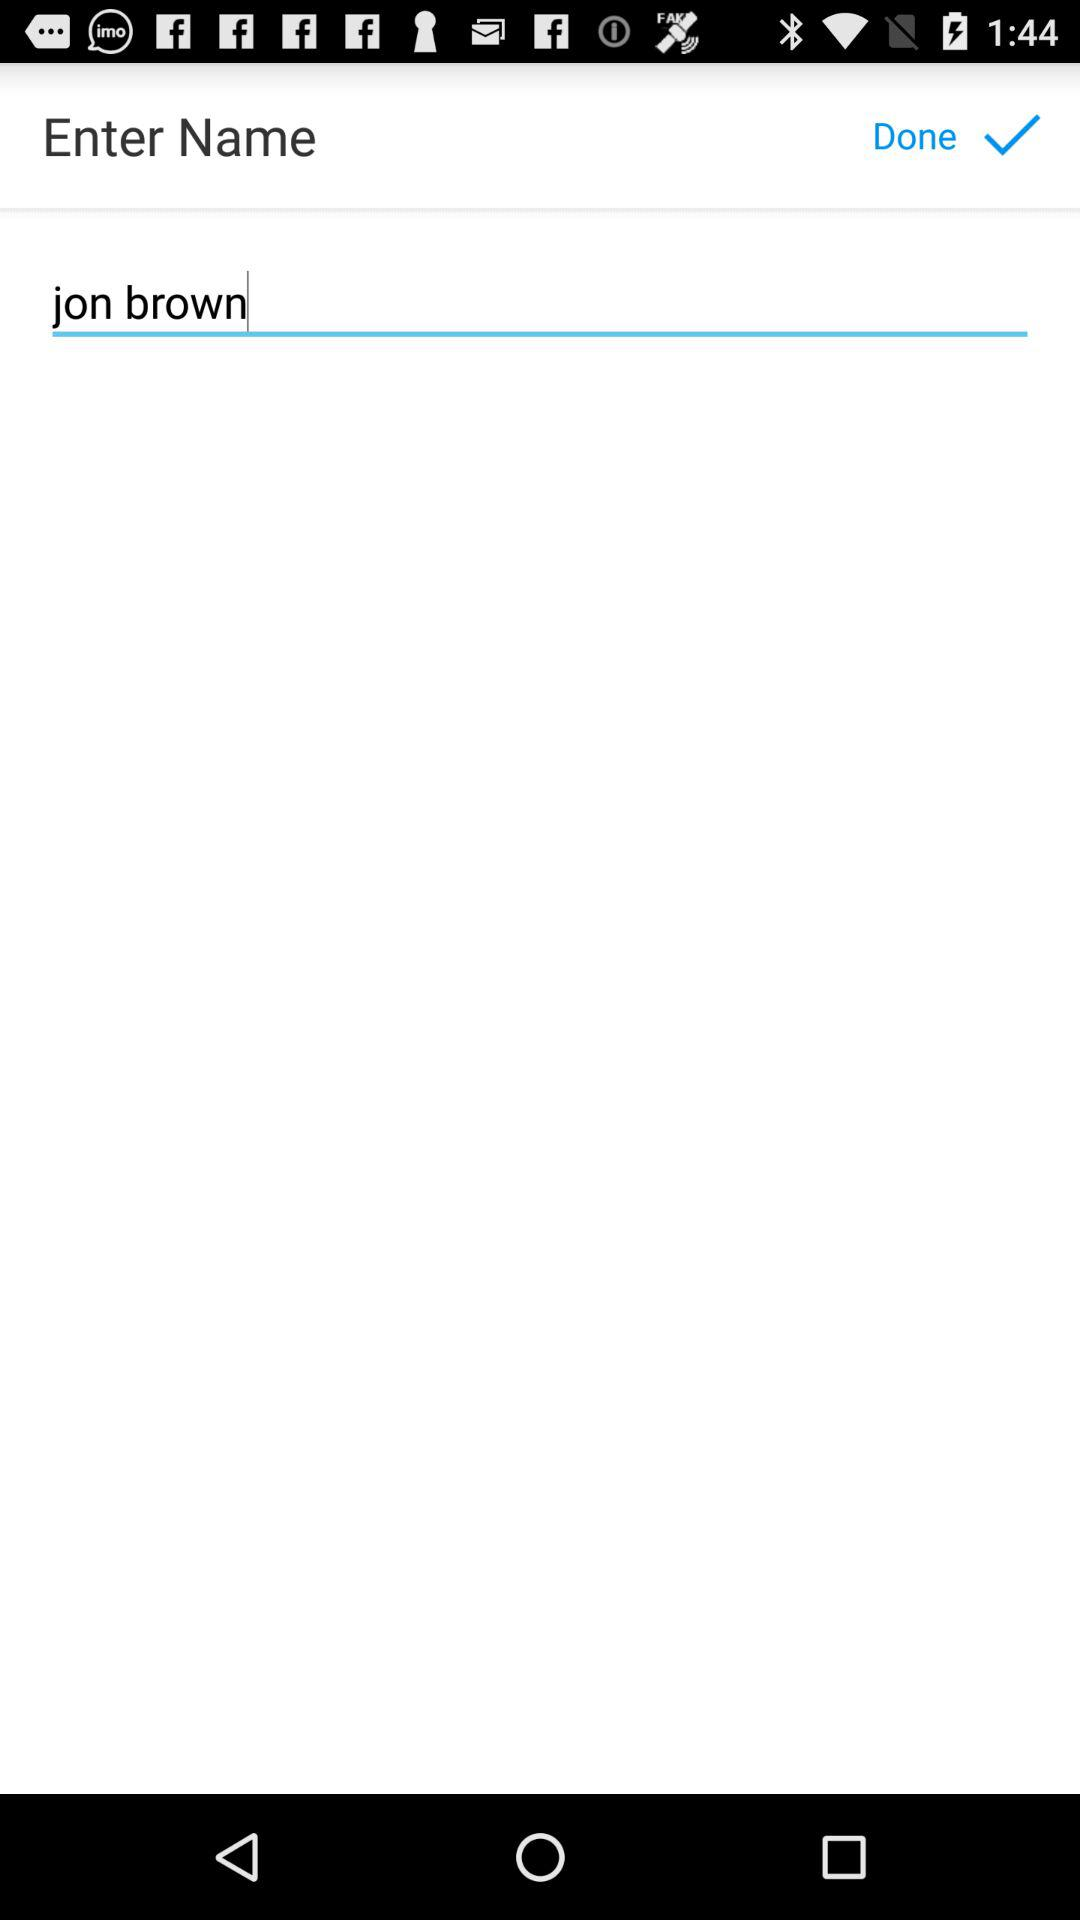What is the name of the user? The name of the user is Jon Brown. 